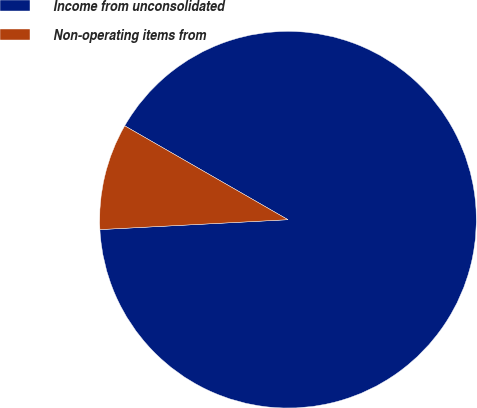Convert chart to OTSL. <chart><loc_0><loc_0><loc_500><loc_500><pie_chart><fcel>Income from unconsolidated<fcel>Non-operating items from<nl><fcel>90.86%<fcel>9.14%<nl></chart> 